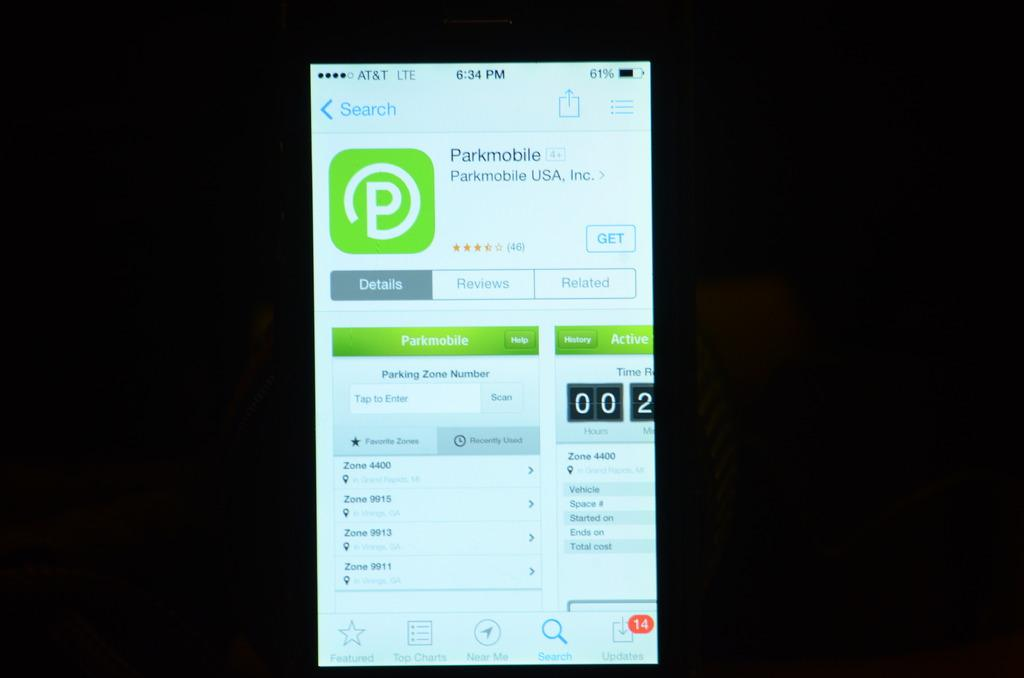<image>
Describe the image concisely. The parkmobile app was made by Parkmobile USA, Inc. 